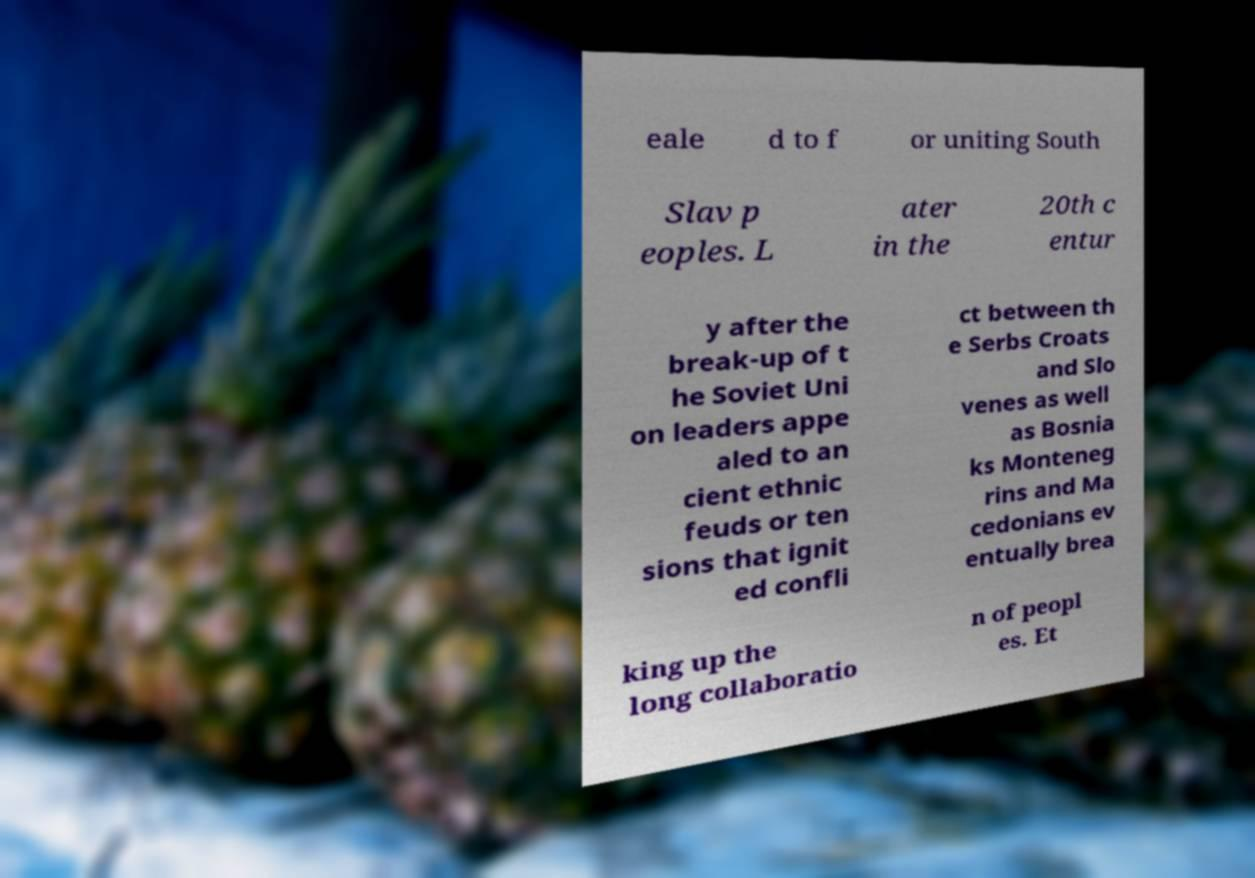Please identify and transcribe the text found in this image. eale d to f or uniting South Slav p eoples. L ater in the 20th c entur y after the break-up of t he Soviet Uni on leaders appe aled to an cient ethnic feuds or ten sions that ignit ed confli ct between th e Serbs Croats and Slo venes as well as Bosnia ks Monteneg rins and Ma cedonians ev entually brea king up the long collaboratio n of peopl es. Et 